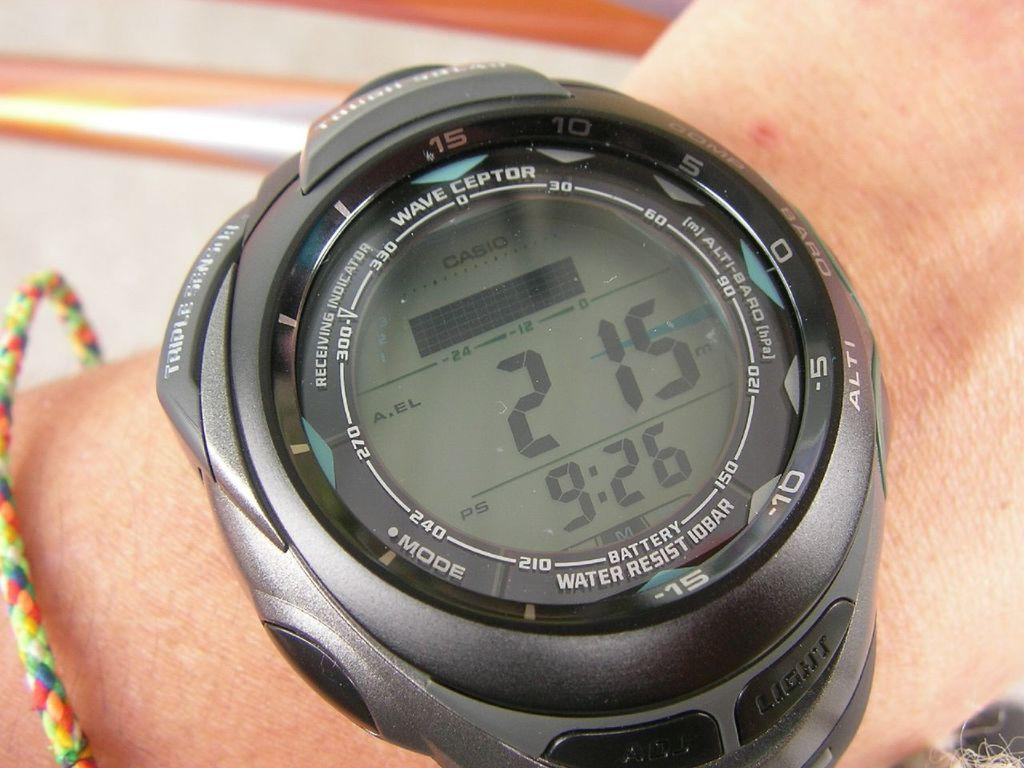<image>
Relay a brief, clear account of the picture shown. A wave ceptor watch shows the time is 9:26. 